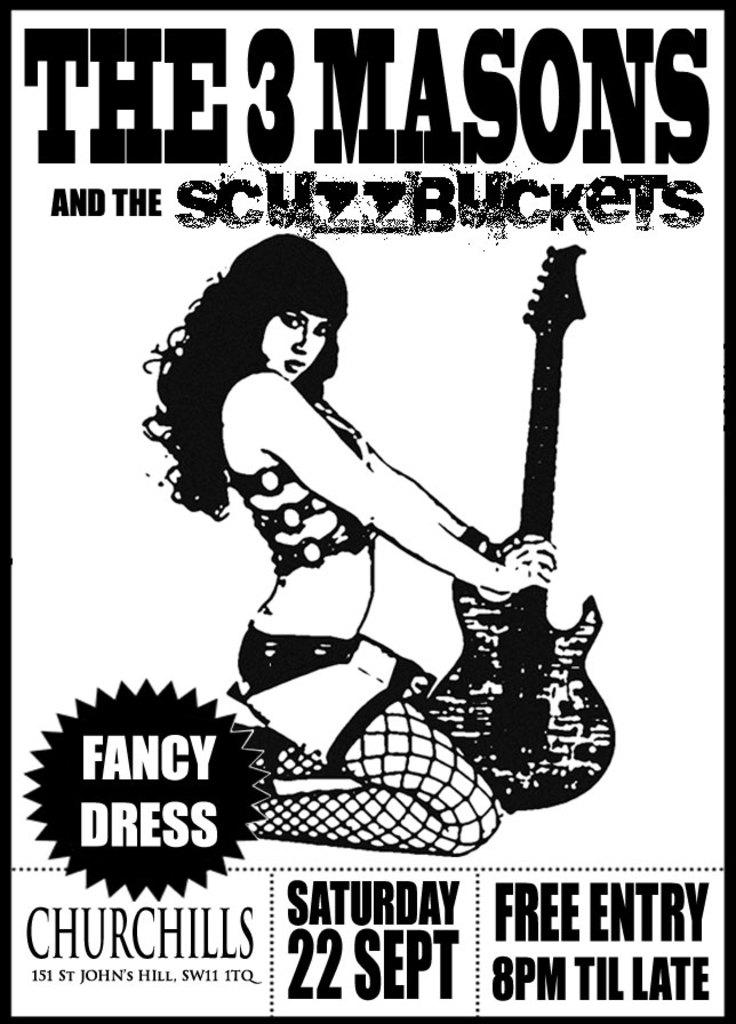What day is the event on?
Offer a very short reply. Saturday 22 sept. What is the name of the band?
Offer a terse response. The 3 masons. 